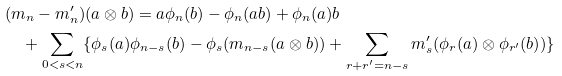Convert formula to latex. <formula><loc_0><loc_0><loc_500><loc_500>& ( m _ { n } - m ^ { \prime } _ { n } ) ( a \otimes b ) = a \phi _ { n } ( b ) - \phi _ { n } ( a b ) + \phi _ { n } ( a ) b \\ & \quad + \sum _ { 0 < s < n } \{ \phi _ { s } ( a ) \phi _ { n - s } ( b ) - \phi _ { s } ( m _ { n - s } ( a \otimes b ) ) + \sum _ { r + r ^ { \prime } = n - s } m ^ { \prime } _ { s } ( \phi _ { r } ( a ) \otimes \phi _ { r ^ { \prime } } ( b ) ) \}</formula> 